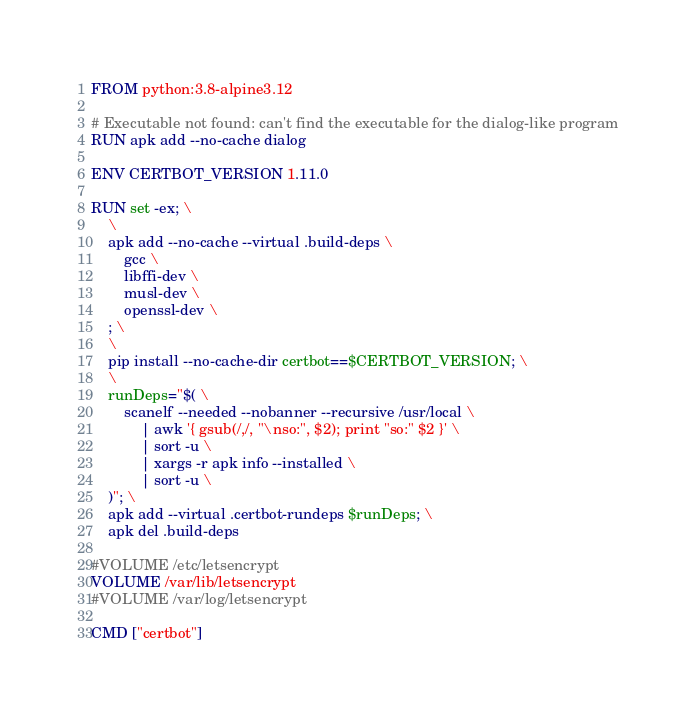<code> <loc_0><loc_0><loc_500><loc_500><_Dockerfile_>FROM python:3.8-alpine3.12

# Executable not found: can't find the executable for the dialog-like program
RUN apk add --no-cache dialog

ENV CERTBOT_VERSION 1.11.0

RUN set -ex; \
	\
	apk add --no-cache --virtual .build-deps \
		gcc \
		libffi-dev \
		musl-dev \
		openssl-dev \
	; \
	\
	pip install --no-cache-dir certbot==$CERTBOT_VERSION; \
	\
	runDeps="$( \
		scanelf --needed --nobanner --recursive /usr/local \
			| awk '{ gsub(/,/, "\nso:", $2); print "so:" $2 }' \
			| sort -u \
			| xargs -r apk info --installed \
			| sort -u \
	)"; \
	apk add --virtual .certbot-rundeps $runDeps; \
	apk del .build-deps

#VOLUME /etc/letsencrypt
VOLUME /var/lib/letsencrypt
#VOLUME /var/log/letsencrypt

CMD ["certbot"]
</code> 